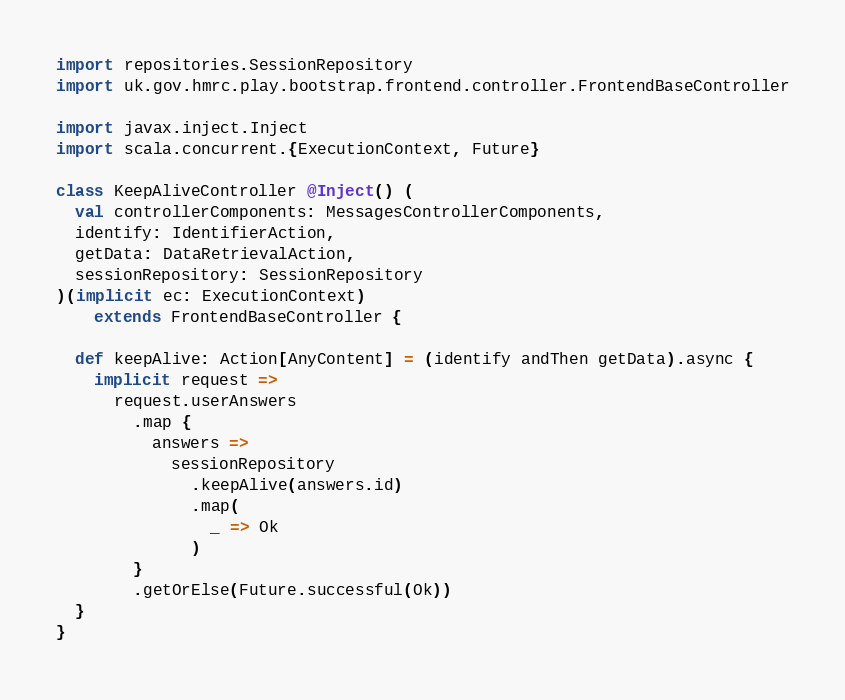Convert code to text. <code><loc_0><loc_0><loc_500><loc_500><_Scala_>import repositories.SessionRepository
import uk.gov.hmrc.play.bootstrap.frontend.controller.FrontendBaseController

import javax.inject.Inject
import scala.concurrent.{ExecutionContext, Future}

class KeepAliveController @Inject() (
  val controllerComponents: MessagesControllerComponents,
  identify: IdentifierAction,
  getData: DataRetrievalAction,
  sessionRepository: SessionRepository
)(implicit ec: ExecutionContext)
    extends FrontendBaseController {

  def keepAlive: Action[AnyContent] = (identify andThen getData).async {
    implicit request =>
      request.userAnswers
        .map {
          answers =>
            sessionRepository
              .keepAlive(answers.id)
              .map(
                _ => Ok
              )
        }
        .getOrElse(Future.successful(Ok))
  }
}
</code> 